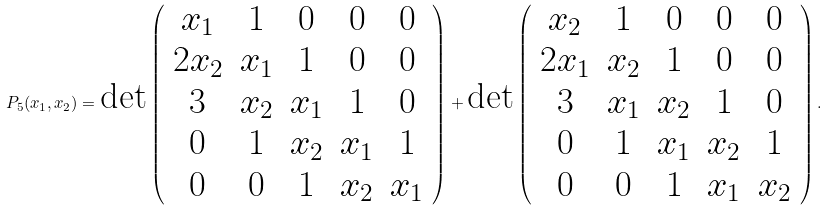Convert formula to latex. <formula><loc_0><loc_0><loc_500><loc_500>P _ { 5 } ( x _ { 1 } , x _ { 2 } ) = \text {det} \left ( \begin{array} { c c c c c } x _ { 1 } & 1 & 0 & 0 & 0 \\ 2 x _ { 2 } & x _ { 1 } & 1 & 0 & 0 \\ 3 & x _ { 2 } & x _ { 1 } & 1 & 0 \\ 0 & 1 & x _ { 2 } & x _ { 1 } & 1 \\ 0 & 0 & 1 & x _ { 2 } & x _ { 1 } \end{array} \right ) + \text {det} \left ( \begin{array} { c c c c c } x _ { 2 } & 1 & 0 & 0 & 0 \\ 2 x _ { 1 } & x _ { 2 } & 1 & 0 & 0 \\ 3 & x _ { 1 } & x _ { 2 } & 1 & 0 \\ 0 & 1 & x _ { 1 } & x _ { 2 } & 1 \\ 0 & 0 & 1 & x _ { 1 } & x _ { 2 } \end{array} \right ) .</formula> 